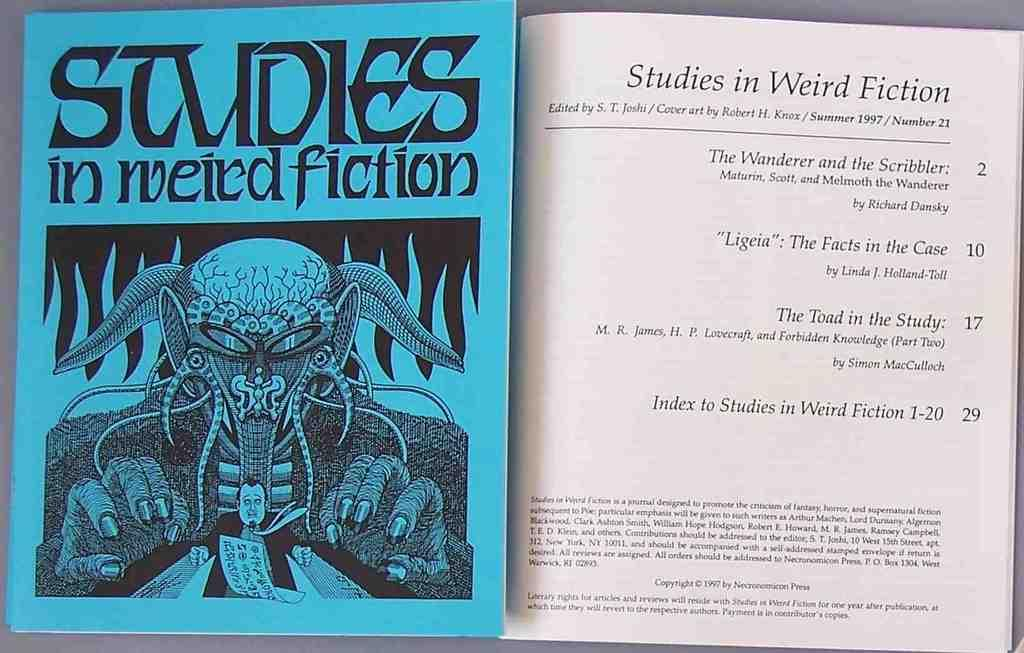<image>
Offer a succinct explanation of the picture presented. A blue covered book with the title studies in weird fiction talks about 4 incidents as seen on the title page. 